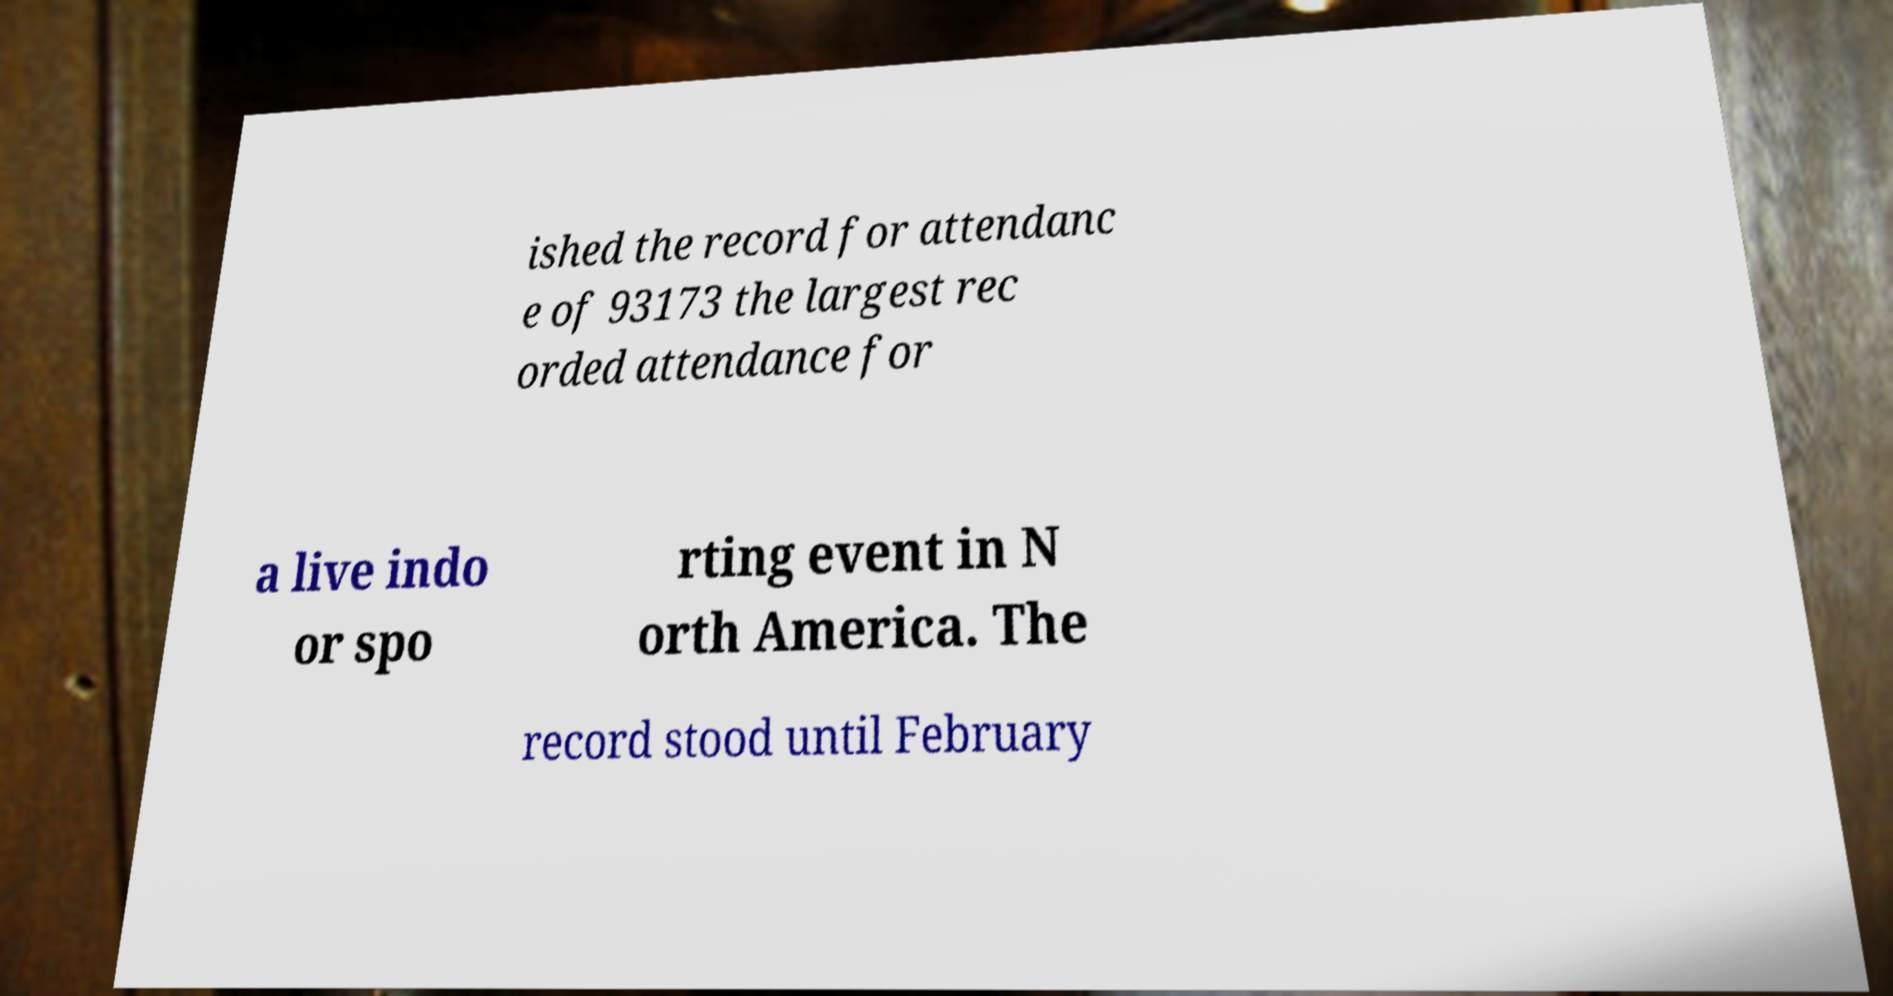There's text embedded in this image that I need extracted. Can you transcribe it verbatim? ished the record for attendanc e of 93173 the largest rec orded attendance for a live indo or spo rting event in N orth America. The record stood until February 